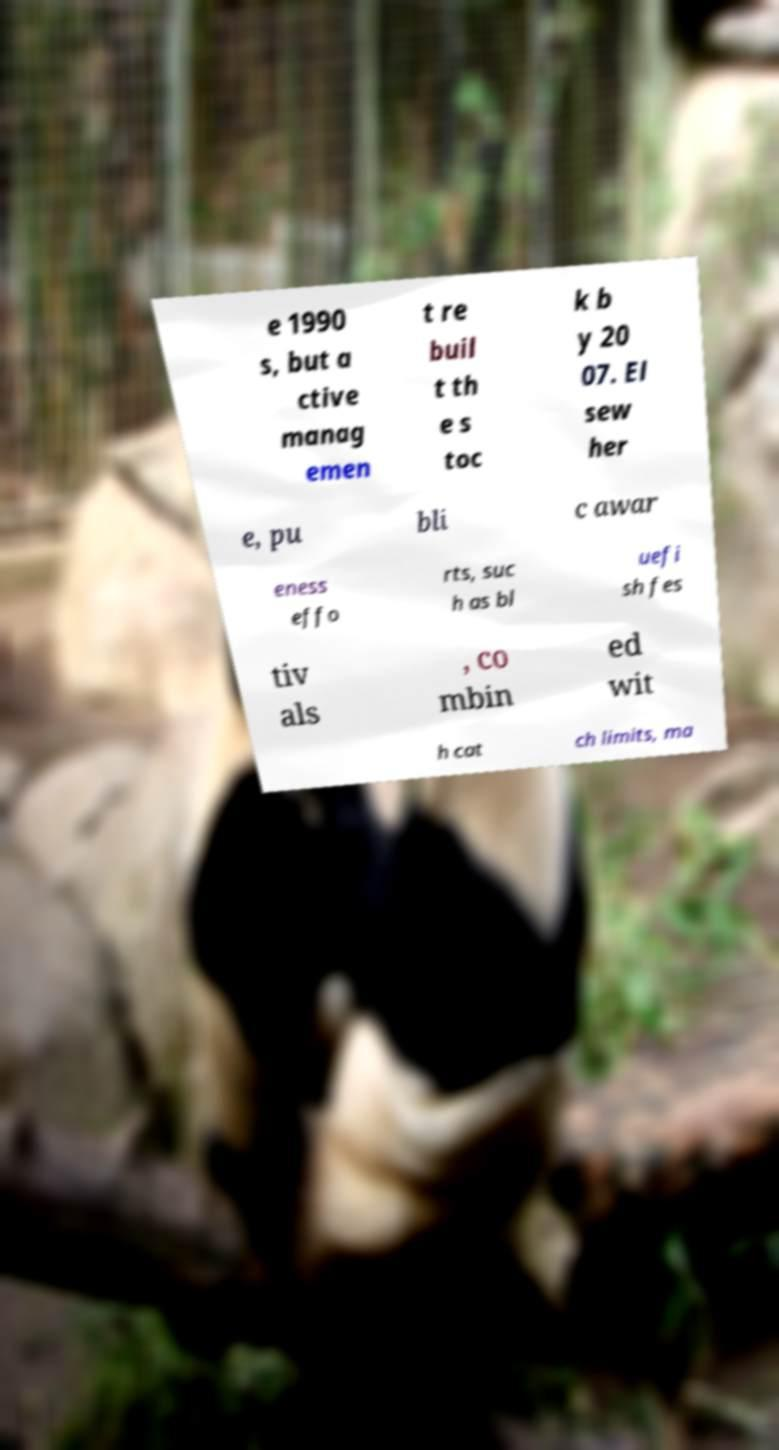Could you extract and type out the text from this image? e 1990 s, but a ctive manag emen t re buil t th e s toc k b y 20 07. El sew her e, pu bli c awar eness effo rts, suc h as bl uefi sh fes tiv als , co mbin ed wit h cat ch limits, ma 